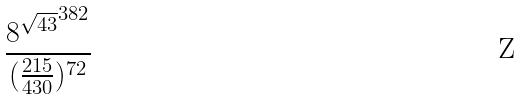Convert formula to latex. <formula><loc_0><loc_0><loc_500><loc_500>\frac { { 8 ^ { \sqrt { 4 3 } } } ^ { 3 8 2 } } { ( \frac { 2 1 5 } { 4 3 0 } ) ^ { 7 2 } }</formula> 